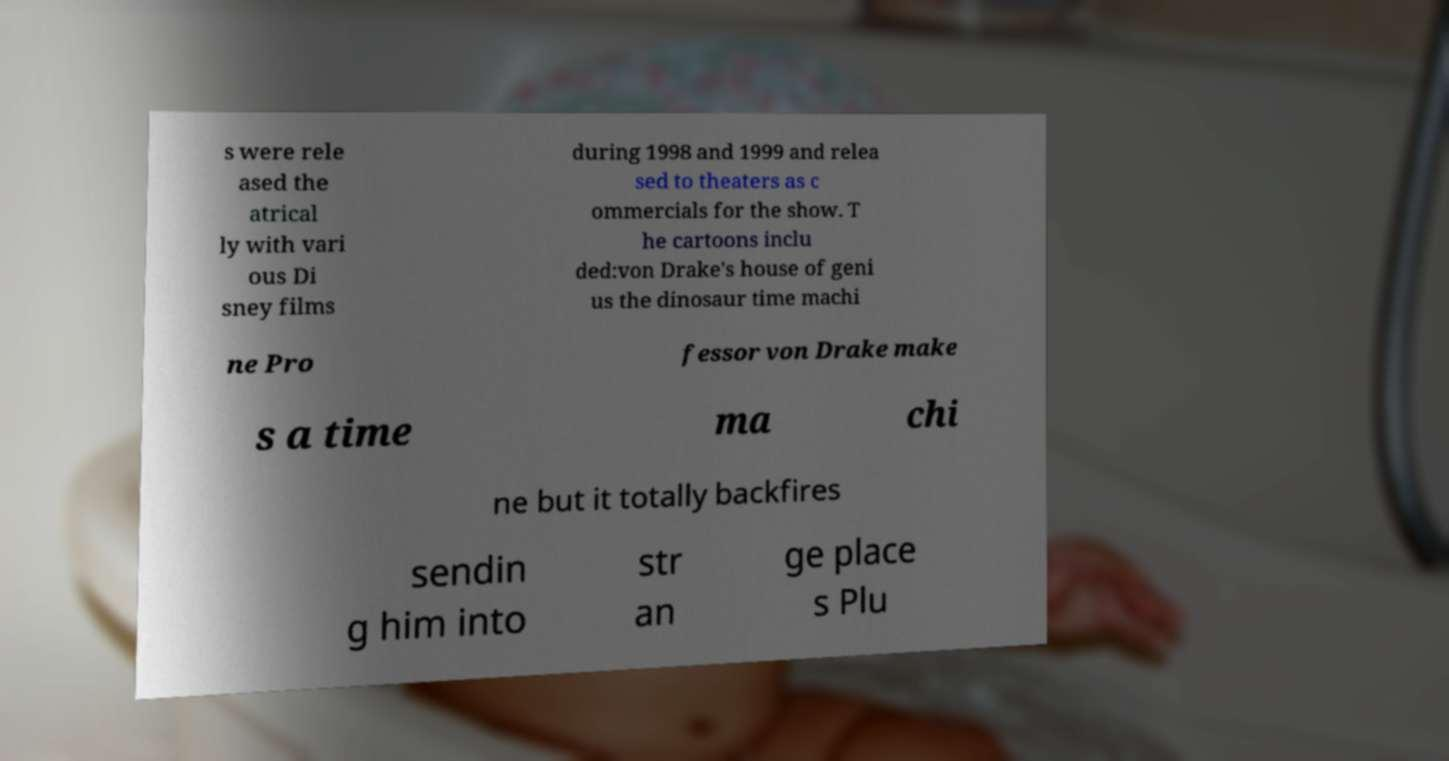For documentation purposes, I need the text within this image transcribed. Could you provide that? s were rele ased the atrical ly with vari ous Di sney films during 1998 and 1999 and relea sed to theaters as c ommercials for the show. T he cartoons inclu ded:von Drake's house of geni us the dinosaur time machi ne Pro fessor von Drake make s a time ma chi ne but it totally backfires sendin g him into str an ge place s Plu 